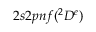<formula> <loc_0><loc_0><loc_500><loc_500>2 s 2 p n f ( ^ { 2 } D ^ { e } )</formula> 